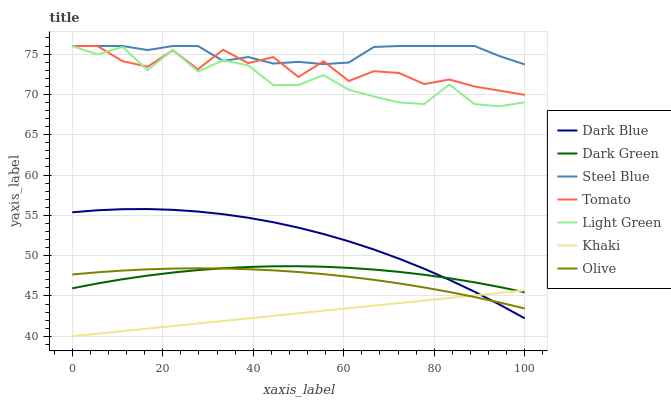Does Khaki have the minimum area under the curve?
Answer yes or no. Yes. Does Steel Blue have the maximum area under the curve?
Answer yes or no. Yes. Does Steel Blue have the minimum area under the curve?
Answer yes or no. No. Does Khaki have the maximum area under the curve?
Answer yes or no. No. Is Khaki the smoothest?
Answer yes or no. Yes. Is Tomato the roughest?
Answer yes or no. Yes. Is Steel Blue the smoothest?
Answer yes or no. No. Is Steel Blue the roughest?
Answer yes or no. No. Does Khaki have the lowest value?
Answer yes or no. Yes. Does Steel Blue have the lowest value?
Answer yes or no. No. Does Light Green have the highest value?
Answer yes or no. Yes. Does Khaki have the highest value?
Answer yes or no. No. Is Olive less than Light Green?
Answer yes or no. Yes. Is Steel Blue greater than Olive?
Answer yes or no. Yes. Does Khaki intersect Dark Green?
Answer yes or no. Yes. Is Khaki less than Dark Green?
Answer yes or no. No. Is Khaki greater than Dark Green?
Answer yes or no. No. Does Olive intersect Light Green?
Answer yes or no. No. 